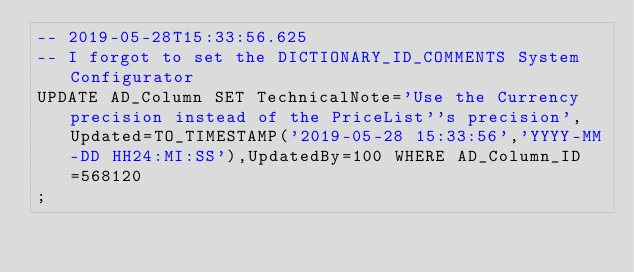<code> <loc_0><loc_0><loc_500><loc_500><_SQL_>-- 2019-05-28T15:33:56.625
-- I forgot to set the DICTIONARY_ID_COMMENTS System Configurator
UPDATE AD_Column SET TechnicalNote='Use the Currency precision instead of the PriceList''s precision',Updated=TO_TIMESTAMP('2019-05-28 15:33:56','YYYY-MM-DD HH24:MI:SS'),UpdatedBy=100 WHERE AD_Column_ID=568120
;

</code> 